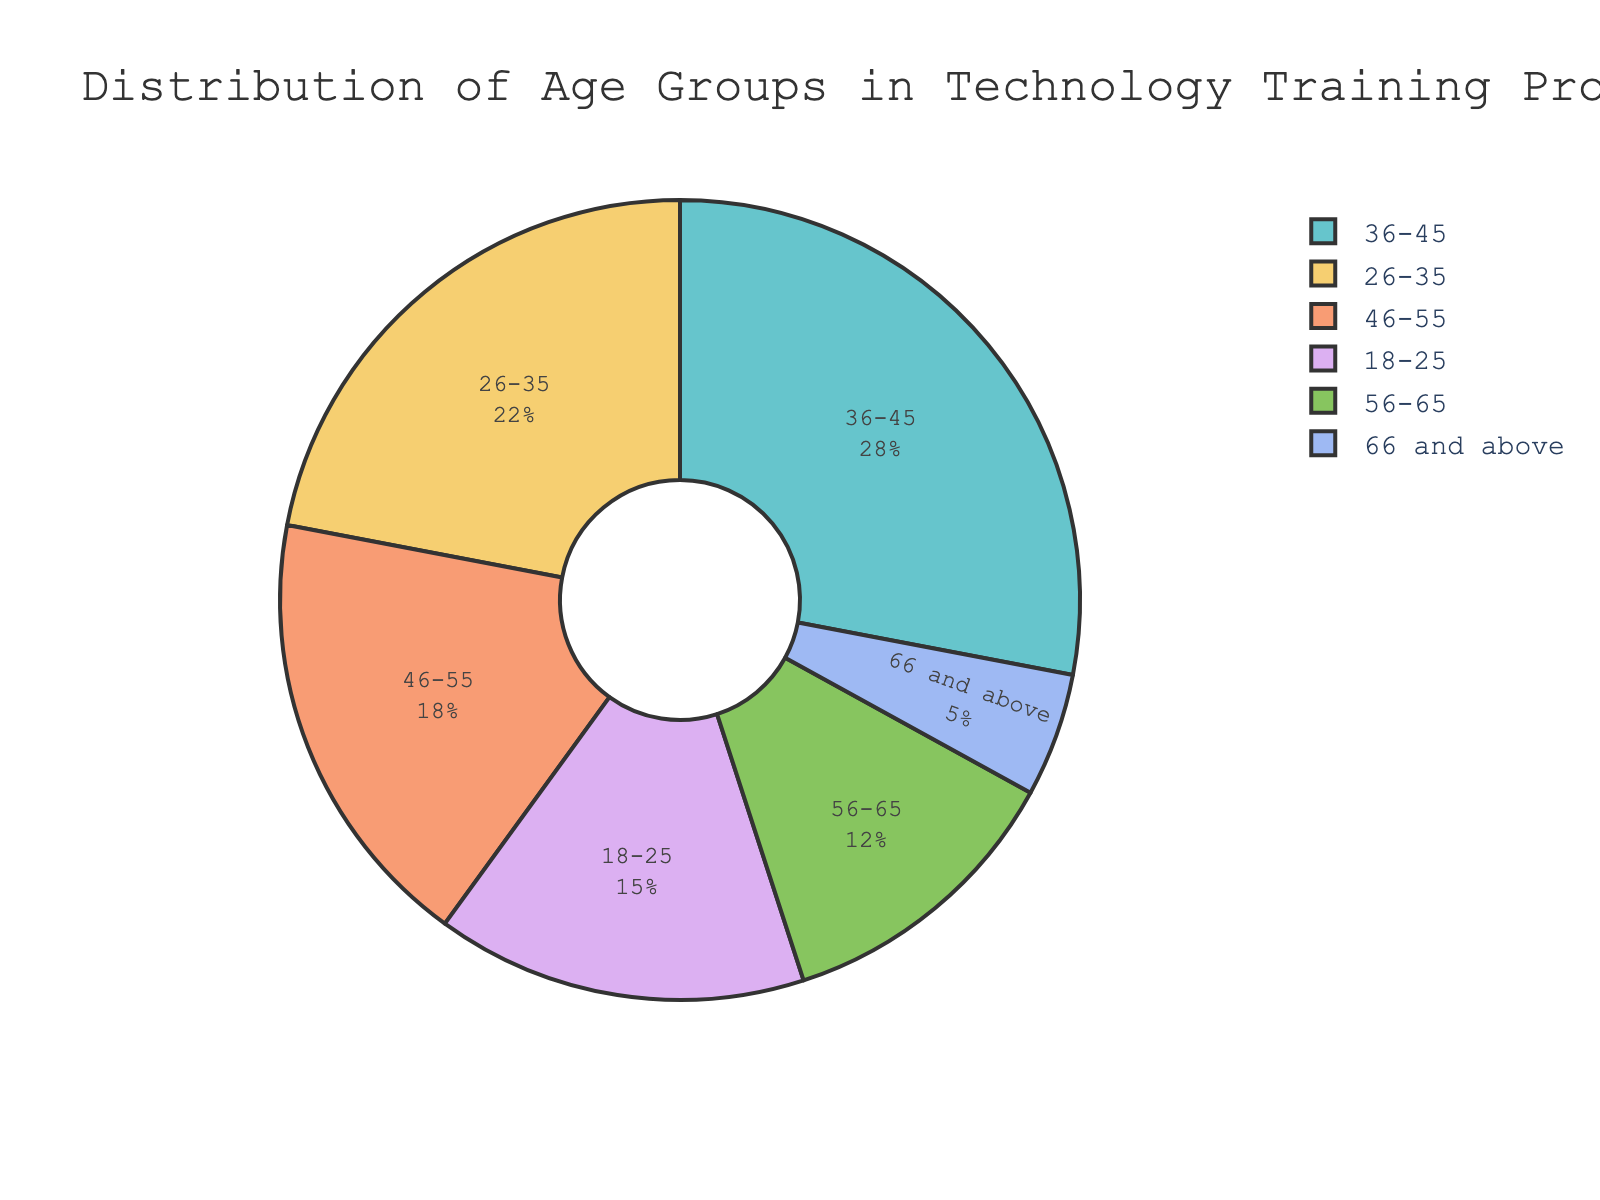Which age group has the largest percentage of participants? The pie chart shows the distribution of age groups within the technology training programs. The segment with the label "36-45" is the largest, indicating it has the highest percentage of participants.
Answer: 36-45 Which two age groups, when combined, form the majority of participants? To determine which two groups form the majority, sum the percentages of different combinations. The combination of "36-45" (28%) and "26-35" (22%) is 50%, which is the majority.
Answer: 36-45 and 26-35 How much larger is the "36-45" group compared to the "66 and above" group? Identify the percentages for "36-45" (28%) and "66 and above" (5%). Subtract the latter from the former: 28 - 5 = 23.
Answer: 23% What percentage of participants are aged 46 and above? Sum the percentages of age groups "46-55" (18%), "56-65" (12%), and "66 and above" (5%): 18 + 12 + 5 = 35.
Answer: 35% What is the least represented age group in the training programs? The pie chart shows varying segment sizes. The segment labeled "66 and above" is the smallest, indicating it has the least participants.
Answer: 66 and above How many age groups have a higher percentage than 20%? Check each segment in the pie chart: the groups "26-35" (22%) and "36-45" (28%) both exceed 20%.
Answer: 2 Which age groups are closest in their percentages? Compare the percentages of each group. "46-55" (18%) and "56-65" (12%) have a difference of 6%, which is smaller than any other pair difference.
Answer: 46-55 and 56-65 What fraction of participants are aged between 18 and 35? Sum the percentages of the "18-25" (15%) and "26-35" (22%) groups: 15 + 22 = 37. The fraction of participants is 37%.
Answer: 37% Which age group segment visually takes up the smallest area in the pie chart? Visually inspecting the pie chart shows that the "66 and above" segment is the smallest.
Answer: 66 and above By how much does the "26-35" group differ from the "56-65" group in percentage terms? Identify the percentages for "26-35" (22%) and "56-65" (12%). Subtract the latter from the former: 22 - 12 = 10.
Answer: 10% 